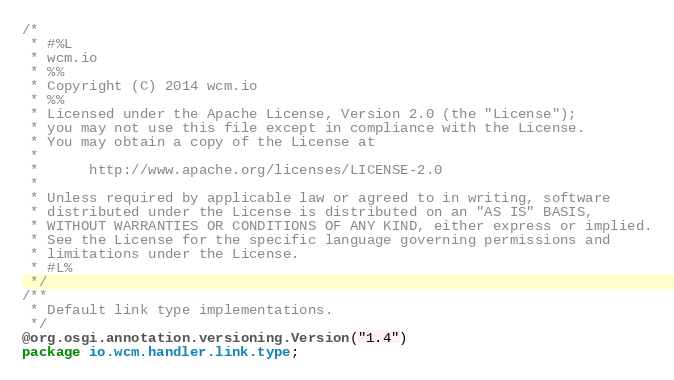<code> <loc_0><loc_0><loc_500><loc_500><_Java_>/*
 * #%L
 * wcm.io
 * %%
 * Copyright (C) 2014 wcm.io
 * %%
 * Licensed under the Apache License, Version 2.0 (the "License");
 * you may not use this file except in compliance with the License.
 * You may obtain a copy of the License at
 *
 *      http://www.apache.org/licenses/LICENSE-2.0
 *
 * Unless required by applicable law or agreed to in writing, software
 * distributed under the License is distributed on an "AS IS" BASIS,
 * WITHOUT WARRANTIES OR CONDITIONS OF ANY KIND, either express or implied.
 * See the License for the specific language governing permissions and
 * limitations under the License.
 * #L%
 */
/**
 * Default link type implementations.
 */
@org.osgi.annotation.versioning.Version("1.4")
package io.wcm.handler.link.type;
</code> 